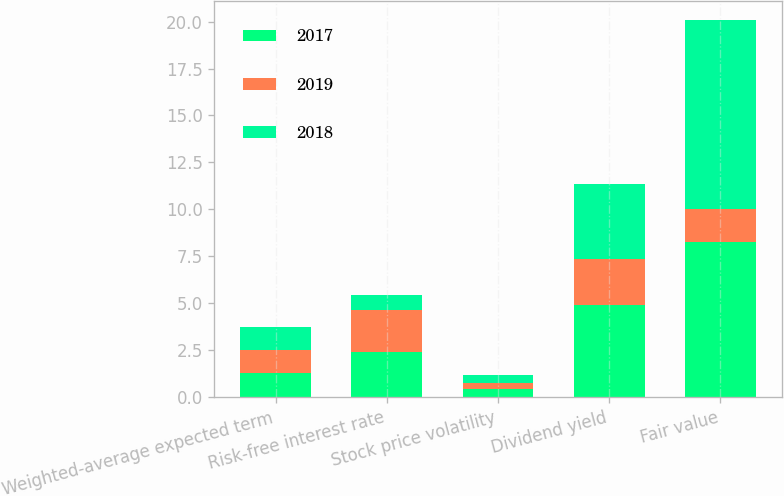Convert chart. <chart><loc_0><loc_0><loc_500><loc_500><stacked_bar_chart><ecel><fcel>Weighted-average expected term<fcel>Risk-free interest rate<fcel>Stock price volatility<fcel>Dividend yield<fcel>Fair value<nl><fcel>2017<fcel>1.26<fcel>2.39<fcel>0.41<fcel>4.92<fcel>8.28<nl><fcel>2019<fcel>1.24<fcel>2.25<fcel>0.35<fcel>2.42<fcel>1.755<nl><fcel>2018<fcel>1.26<fcel>0.81<fcel>0.42<fcel>4.02<fcel>10.06<nl></chart> 